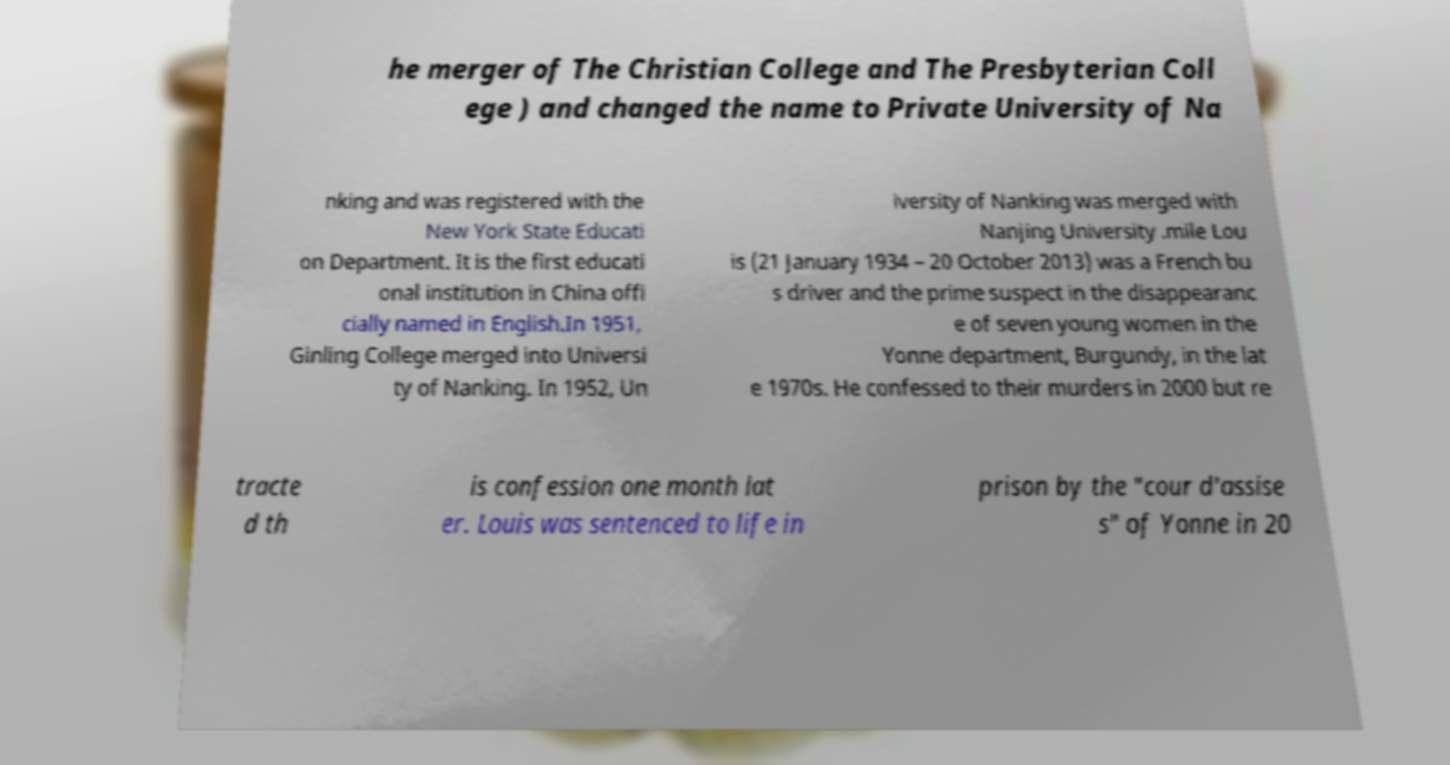There's text embedded in this image that I need extracted. Can you transcribe it verbatim? he merger of The Christian College and The Presbyterian Coll ege ) and changed the name to Private University of Na nking and was registered with the New York State Educati on Department. It is the first educati onal institution in China offi cially named in English.In 1951, Ginling College merged into Universi ty of Nanking. In 1952, Un iversity of Nanking was merged with Nanjing University .mile Lou is (21 January 1934 – 20 October 2013) was a French bu s driver and the prime suspect in the disappearanc e of seven young women in the Yonne department, Burgundy, in the lat e 1970s. He confessed to their murders in 2000 but re tracte d th is confession one month lat er. Louis was sentenced to life in prison by the "cour d'assise s" of Yonne in 20 